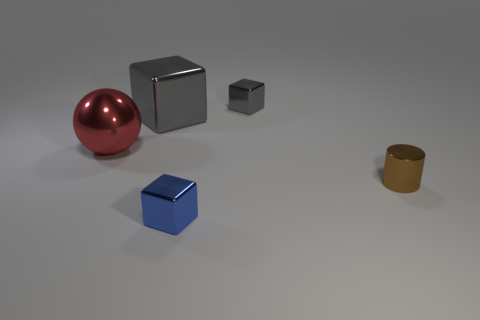Are there any other things that have the same material as the blue block?
Make the answer very short. Yes. There is another tiny thing that is the same shape as the small blue metal thing; what material is it?
Offer a terse response. Metal. Are there the same number of balls left of the red sphere and small yellow cylinders?
Ensure brevity in your answer.  Yes. What size is the metal block that is to the right of the large gray cube and behind the shiny cylinder?
Offer a very short reply. Small. Is there anything else that has the same color as the sphere?
Provide a short and direct response. No. What size is the gray metallic object that is to the left of the small metal block that is to the right of the tiny blue cube?
Your response must be concise. Large. There is a metallic object that is both to the right of the blue thing and behind the tiny metal cylinder; what color is it?
Provide a succinct answer. Gray. What number of other objects are there of the same size as the metal cylinder?
Your response must be concise. 2. Does the metallic sphere have the same size as the metallic block in front of the large ball?
Keep it short and to the point. No. There is a cube that is the same size as the red metal object; what is its color?
Keep it short and to the point. Gray. 